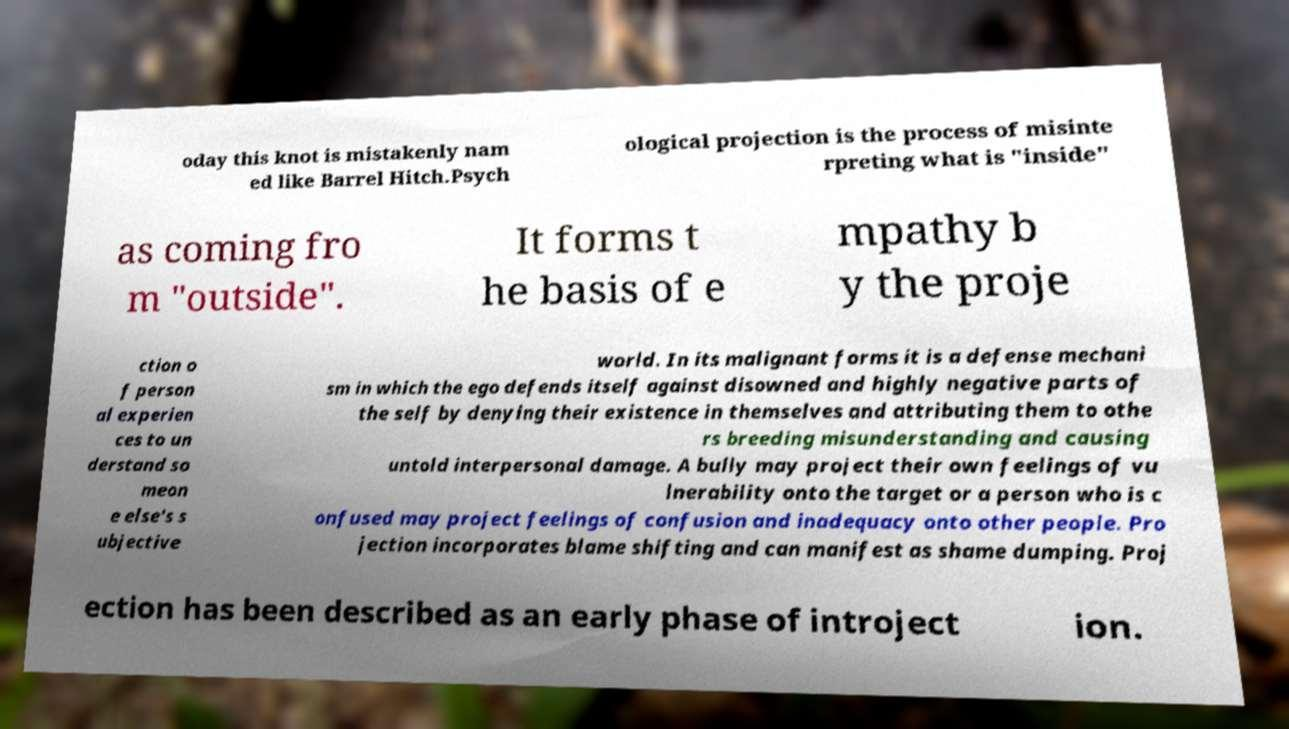Please read and relay the text visible in this image. What does it say? oday this knot is mistakenly nam ed like Barrel Hitch.Psych ological projection is the process of misinte rpreting what is "inside" as coming fro m "outside". It forms t he basis of e mpathy b y the proje ction o f person al experien ces to un derstand so meon e else's s ubjective world. In its malignant forms it is a defense mechani sm in which the ego defends itself against disowned and highly negative parts of the self by denying their existence in themselves and attributing them to othe rs breeding misunderstanding and causing untold interpersonal damage. A bully may project their own feelings of vu lnerability onto the target or a person who is c onfused may project feelings of confusion and inadequacy onto other people. Pro jection incorporates blame shifting and can manifest as shame dumping. Proj ection has been described as an early phase of introject ion. 